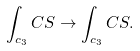<formula> <loc_0><loc_0><loc_500><loc_500>\int _ { c _ { 3 } } C S \rightarrow \int _ { c _ { 3 } } C S .</formula> 